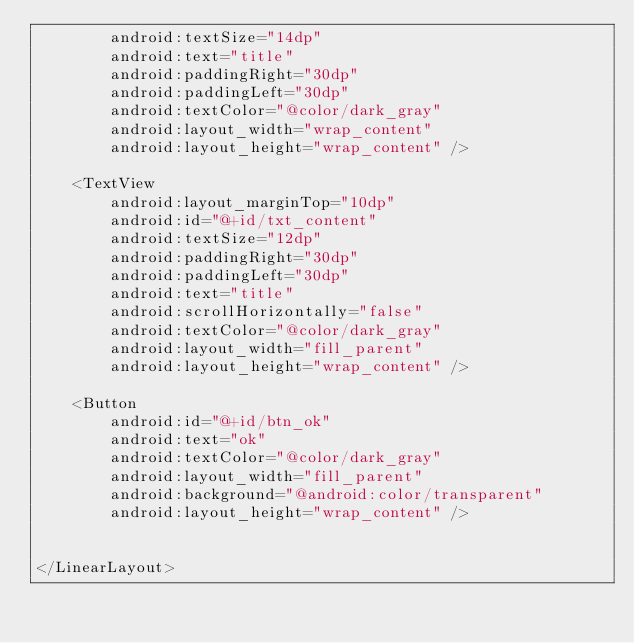<code> <loc_0><loc_0><loc_500><loc_500><_XML_>        android:textSize="14dp"
        android:text="title"
        android:paddingRight="30dp"
        android:paddingLeft="30dp"
        android:textColor="@color/dark_gray"
        android:layout_width="wrap_content"
        android:layout_height="wrap_content" />

    <TextView
        android:layout_marginTop="10dp"
        android:id="@+id/txt_content"
        android:textSize="12dp"
        android:paddingRight="30dp"
        android:paddingLeft="30dp"
        android:text="title"
        android:scrollHorizontally="false"
        android:textColor="@color/dark_gray"
        android:layout_width="fill_parent"
        android:layout_height="wrap_content" />

    <Button
        android:id="@+id/btn_ok"
        android:text="ok"
        android:textColor="@color/dark_gray"
        android:layout_width="fill_parent"
        android:background="@android:color/transparent"
        android:layout_height="wrap_content" />


</LinearLayout></code> 